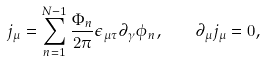Convert formula to latex. <formula><loc_0><loc_0><loc_500><loc_500>j _ { \mu } = \sum _ { n = 1 } ^ { N - 1 } \frac { \Phi _ { n } } { 2 \pi } \epsilon _ { \mu \tau } \partial _ { \gamma } \phi _ { n } , \quad \partial _ { \mu } j _ { \mu } = 0 ,</formula> 